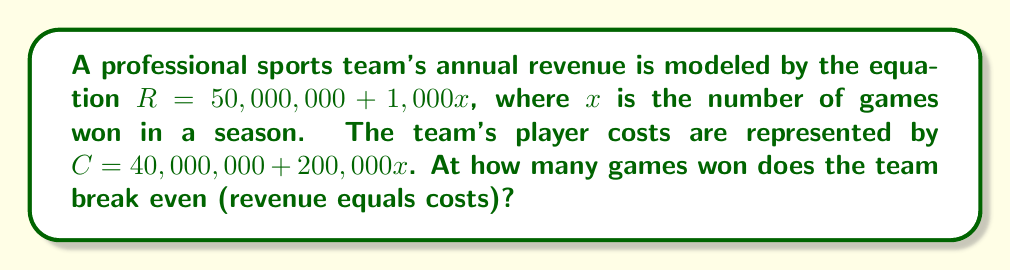Help me with this question. To find the break-even point, we need to set the revenue (R) equal to the costs (C) and solve for x:

1) Set up the equation:
   $R = C$
   $50,000,000 + 1,000x = 40,000,000 + 200,000x$

2) Subtract 40,000,000 from both sides:
   $10,000,000 + 1,000x = 200,000x$

3) Subtract 1,000x from both sides:
   $10,000,000 = 199,000x$

4) Divide both sides by 199,000:
   $\frac{10,000,000}{199,000} = x$

5) Simplify:
   $x \approx 50.25$

Since the number of games won must be a whole number, we round up to 51 games. At 51 games, the team will have slightly more revenue than costs, achieving the break-even point.
Answer: 51 games 